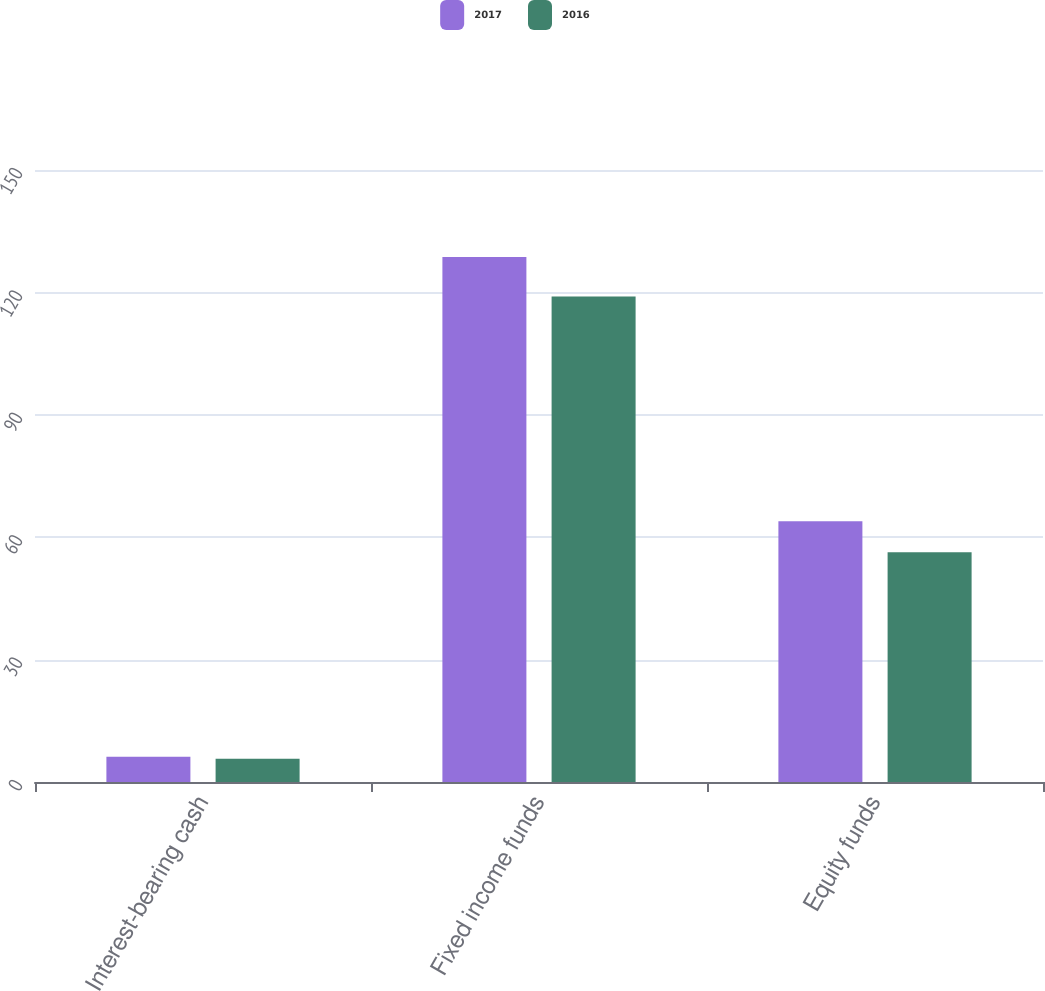<chart> <loc_0><loc_0><loc_500><loc_500><stacked_bar_chart><ecel><fcel>Interest-bearing cash<fcel>Fixed income funds<fcel>Equity funds<nl><fcel>2017<fcel>6.2<fcel>128.7<fcel>63.9<nl><fcel>2016<fcel>5.7<fcel>119<fcel>56.3<nl></chart> 